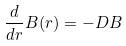Convert formula to latex. <formula><loc_0><loc_0><loc_500><loc_500>\frac { d } { d r } B ( r ) = - D B</formula> 